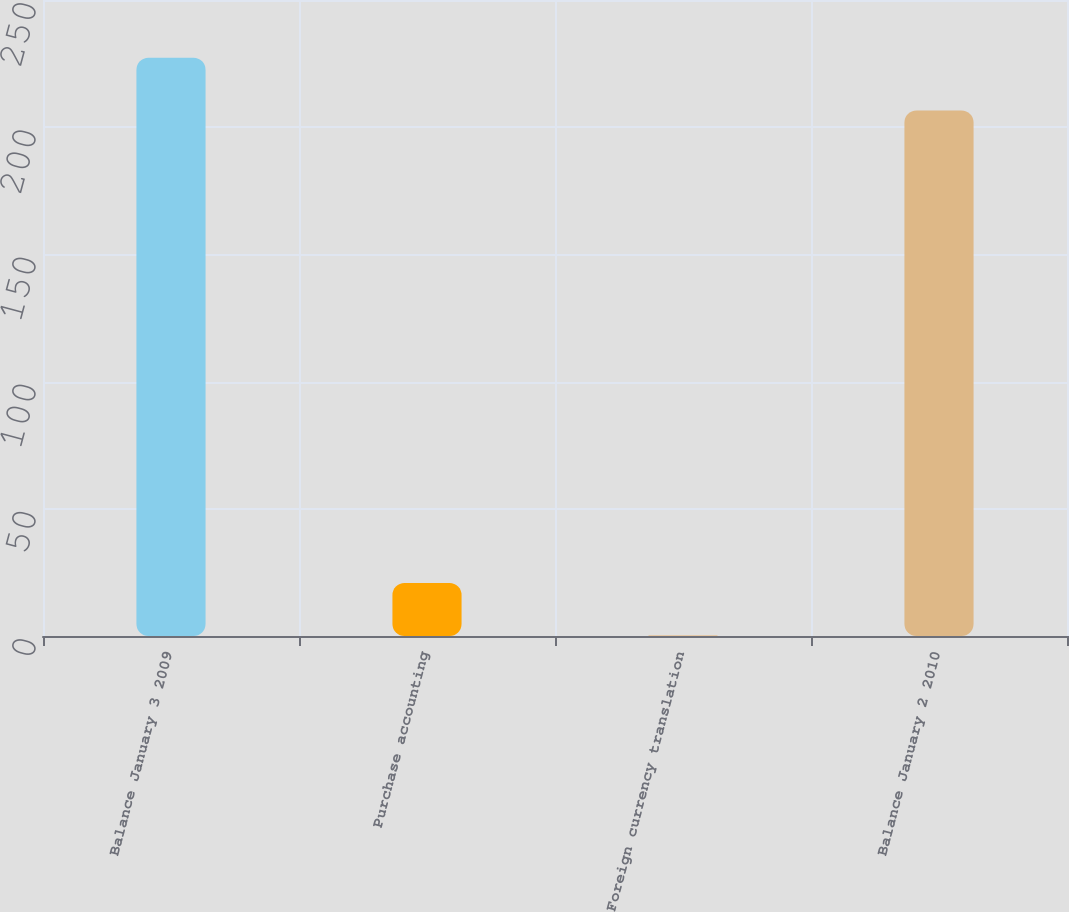Convert chart to OTSL. <chart><loc_0><loc_0><loc_500><loc_500><bar_chart><fcel>Balance January 3 2009<fcel>Purchase accounting<fcel>Foreign currency translation<fcel>Balance January 2 2010<nl><fcel>227.32<fcel>20.82<fcel>0.1<fcel>206.6<nl></chart> 